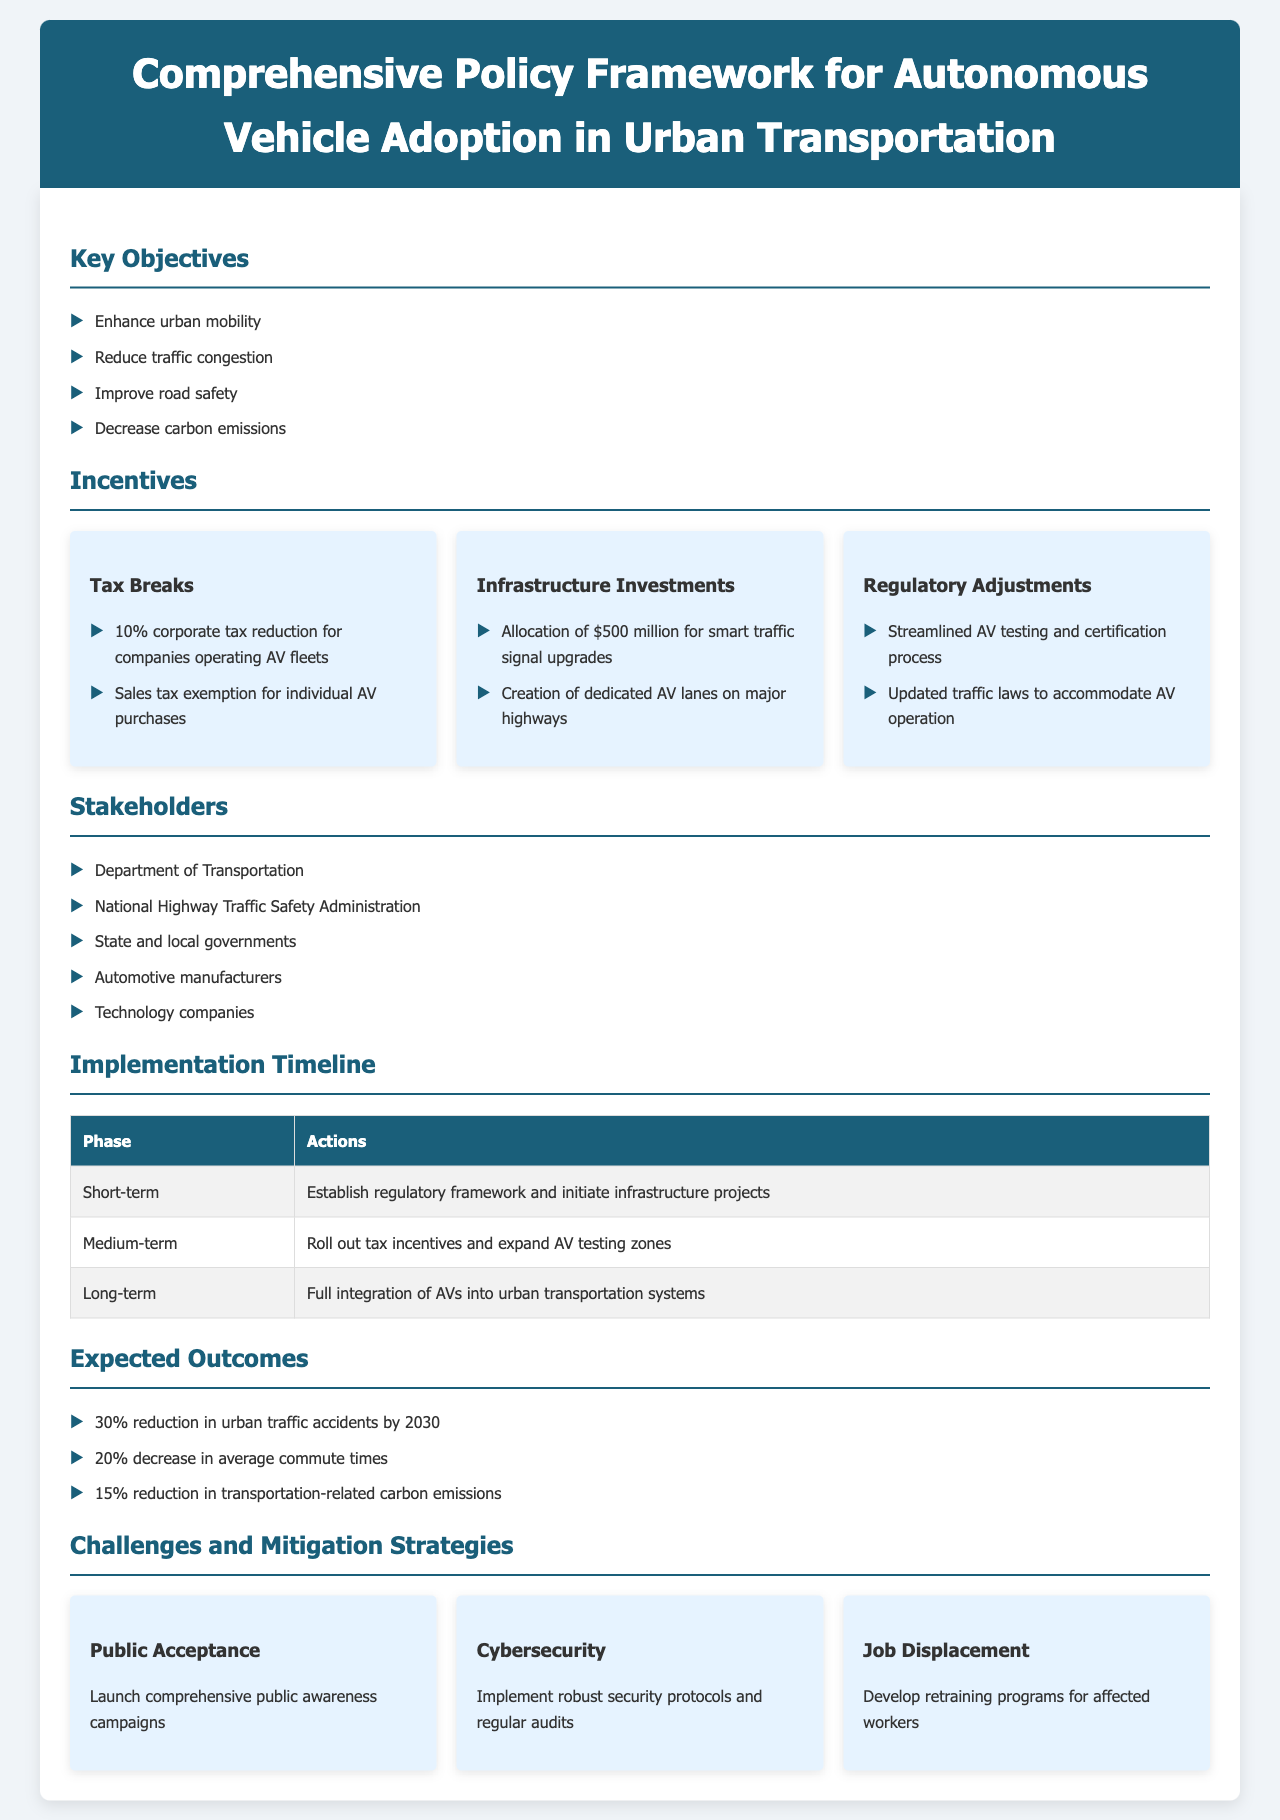What are the key objectives of the policy framework? The key objectives are listed in the document under "Key Objectives," including items such as enhancing urban mobility and reducing traffic congestion.
Answer: Enhance urban mobility, reduce traffic congestion, improve road safety, decrease carbon emissions What is the total funding allocated for smart traffic signal upgrades? The document states that $500 million is allocated specifically for smart traffic signal upgrades under "Infrastructure Investments."
Answer: $500 million What percentage of corporate tax reduction is proposed for companies operating AV fleets? The document mentions a "10% corporate tax reduction" as part of the incentives for companies operating AV fleets.
Answer: 10% What is the first phase of the implementation timeline? The implementation timeline is categorized into phases, and the first phase listed is "Short-term."
Answer: Short-term What is one of the expected outcomes by 2030 related to traffic accidents? The document states that there is an expectation of a "30% reduction in urban traffic accidents by 2030" as an expected outcome.
Answer: 30% reduction Which stakeholders are involved in the policy framework? The document lists several stakeholders involved in the policy, including the Department of Transportation and automotive manufacturers.
Answer: Department of Transportation, National Highway Traffic Safety Administration, State and local governments, Automotive manufacturers, Technology companies What is one challenge mentioned in the document regarding public acceptance? The challenge of public acceptance is addressed in the document, with the proposed solution being "Launch comprehensive public awareness campaigns."
Answer: Launch comprehensive public awareness campaigns What is the medium-term action in the implementation timeline? In the implementation timeline table, the medium-term action mentioned is "Roll out tax incentives and expand AV testing zones."
Answer: Roll out tax incentives and expand AV testing zones What cybersecurity measure is proposed in the challenges section? To address cybersecurity challenges, the document suggests implementing "robust security protocols and regular audits."
Answer: Robust security protocols and regular audits 